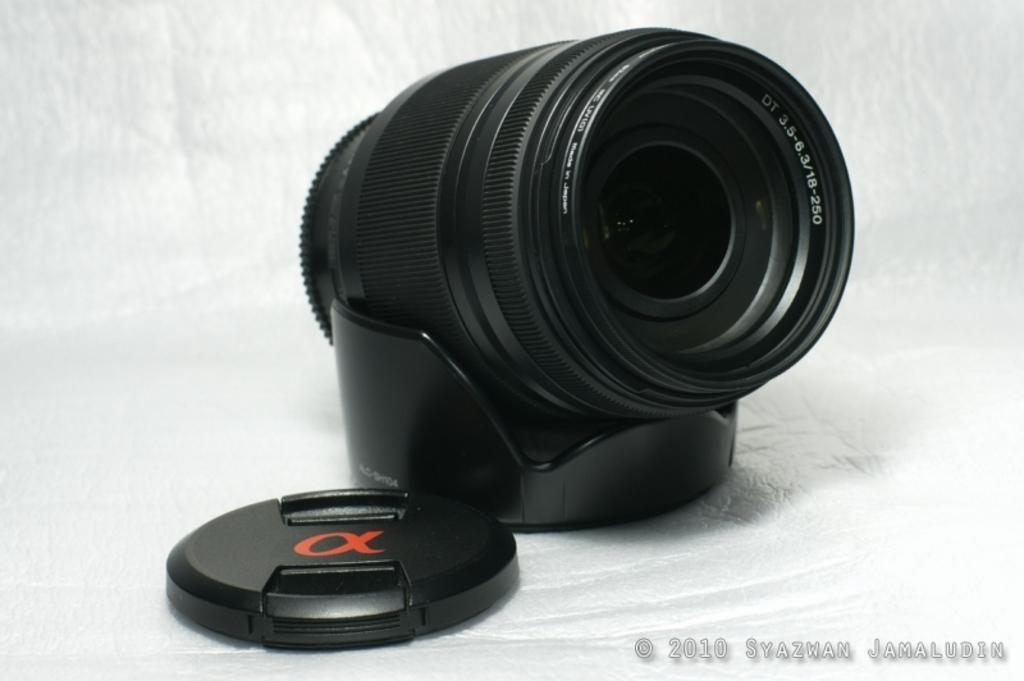Provide a one-sentence caption for the provided image. A black lens with a watermark of 2010 Syazwan Jamaludin on the bottom. 